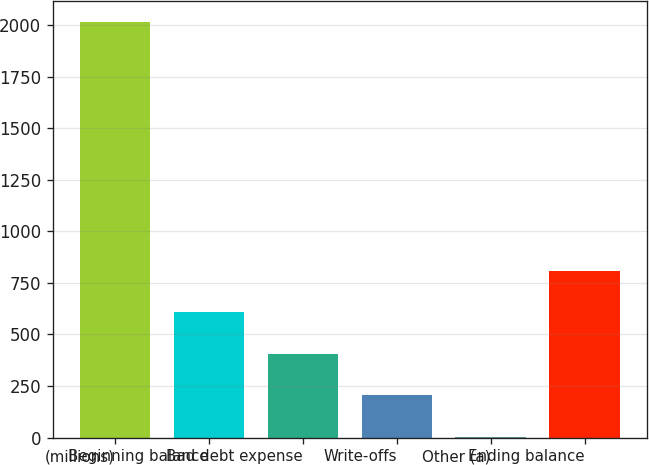Convert chart. <chart><loc_0><loc_0><loc_500><loc_500><bar_chart><fcel>(millions)<fcel>Beginning balance<fcel>Bad debt expense<fcel>Write-offs<fcel>Other (a)<fcel>Ending balance<nl><fcel>2017<fcel>606.85<fcel>405.4<fcel>203.95<fcel>2.5<fcel>808.3<nl></chart> 